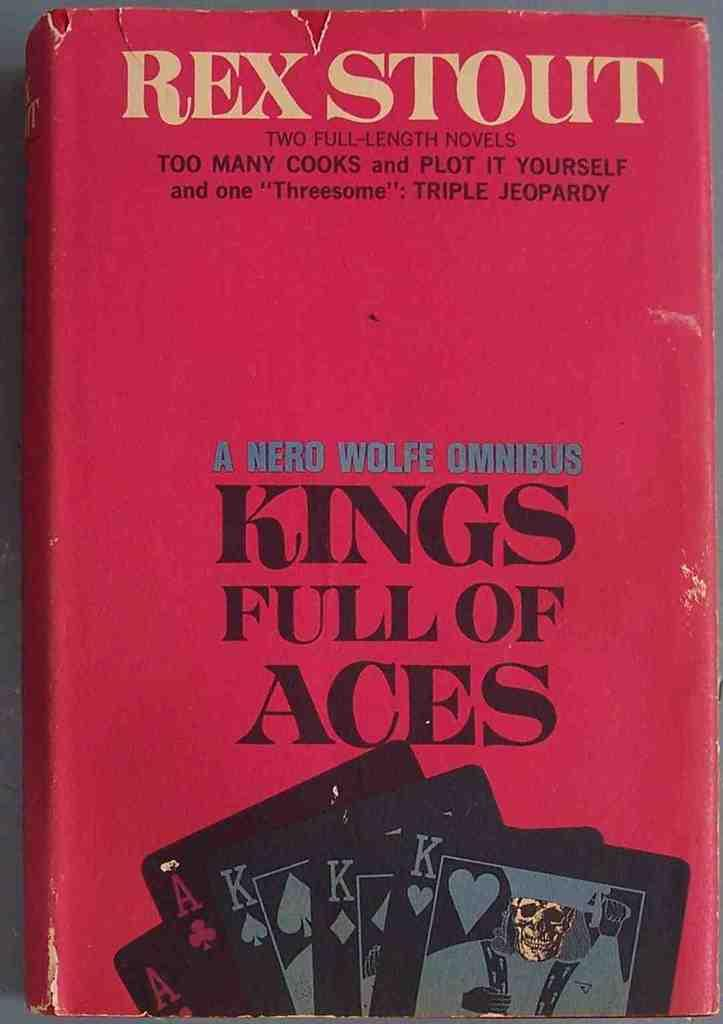Provide a one-sentence caption for the provided image. A book by Rex Scott titled Kings full of aces. 